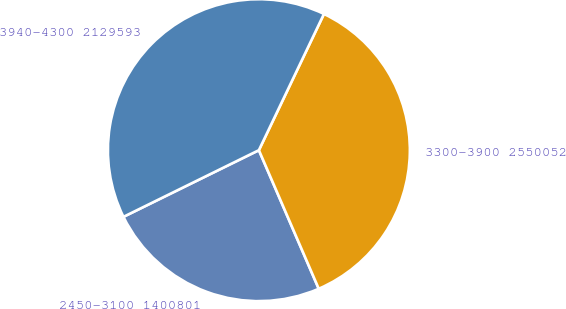<chart> <loc_0><loc_0><loc_500><loc_500><pie_chart><fcel>2450-3100 1400801<fcel>3300-3900 2550052<fcel>3940-4300 2129593<nl><fcel>24.21%<fcel>36.42%<fcel>39.37%<nl></chart> 